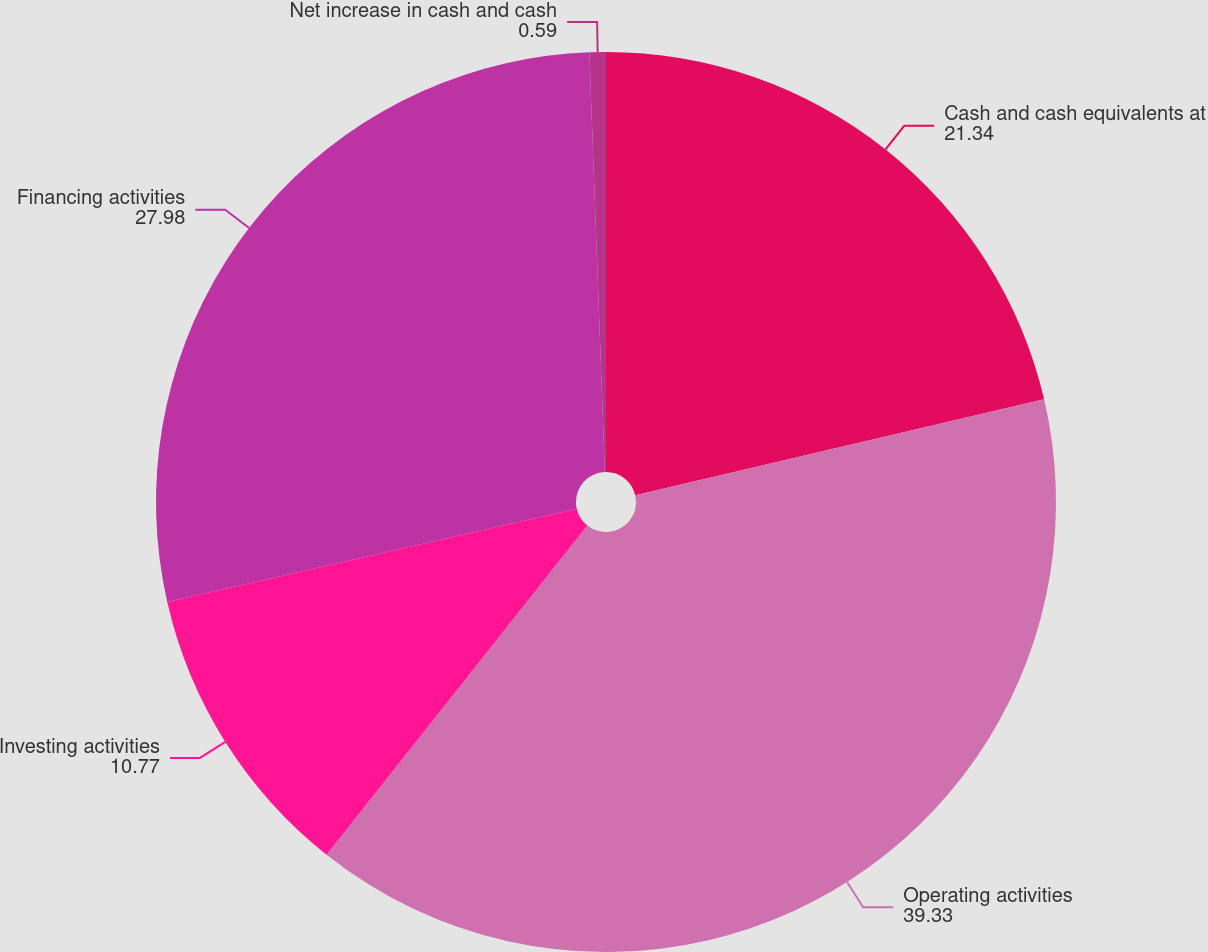Convert chart. <chart><loc_0><loc_0><loc_500><loc_500><pie_chart><fcel>Cash and cash equivalents at<fcel>Operating activities<fcel>Investing activities<fcel>Financing activities<fcel>Net increase in cash and cash<nl><fcel>21.34%<fcel>39.33%<fcel>10.77%<fcel>27.98%<fcel>0.59%<nl></chart> 